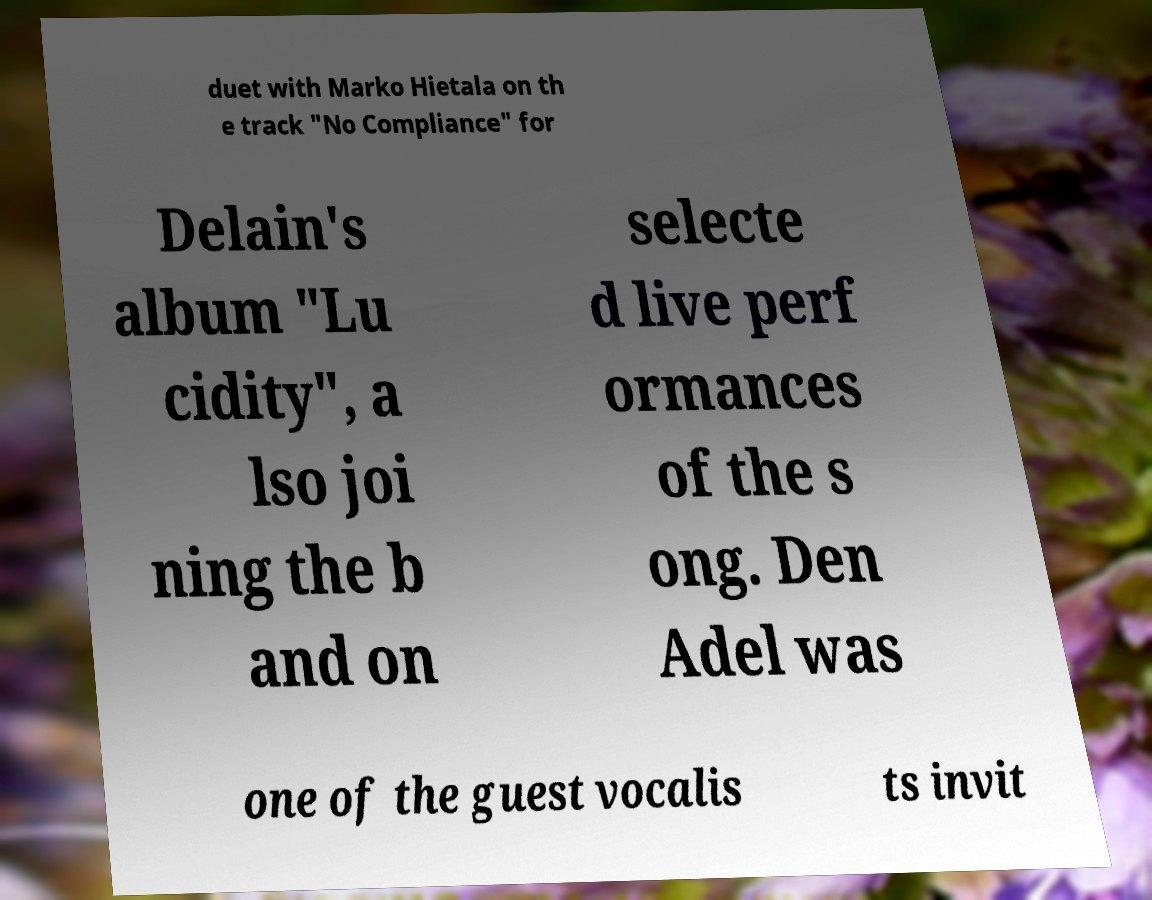Can you accurately transcribe the text from the provided image for me? duet with Marko Hietala on th e track "No Compliance" for Delain's album "Lu cidity", a lso joi ning the b and on selecte d live perf ormances of the s ong. Den Adel was one of the guest vocalis ts invit 